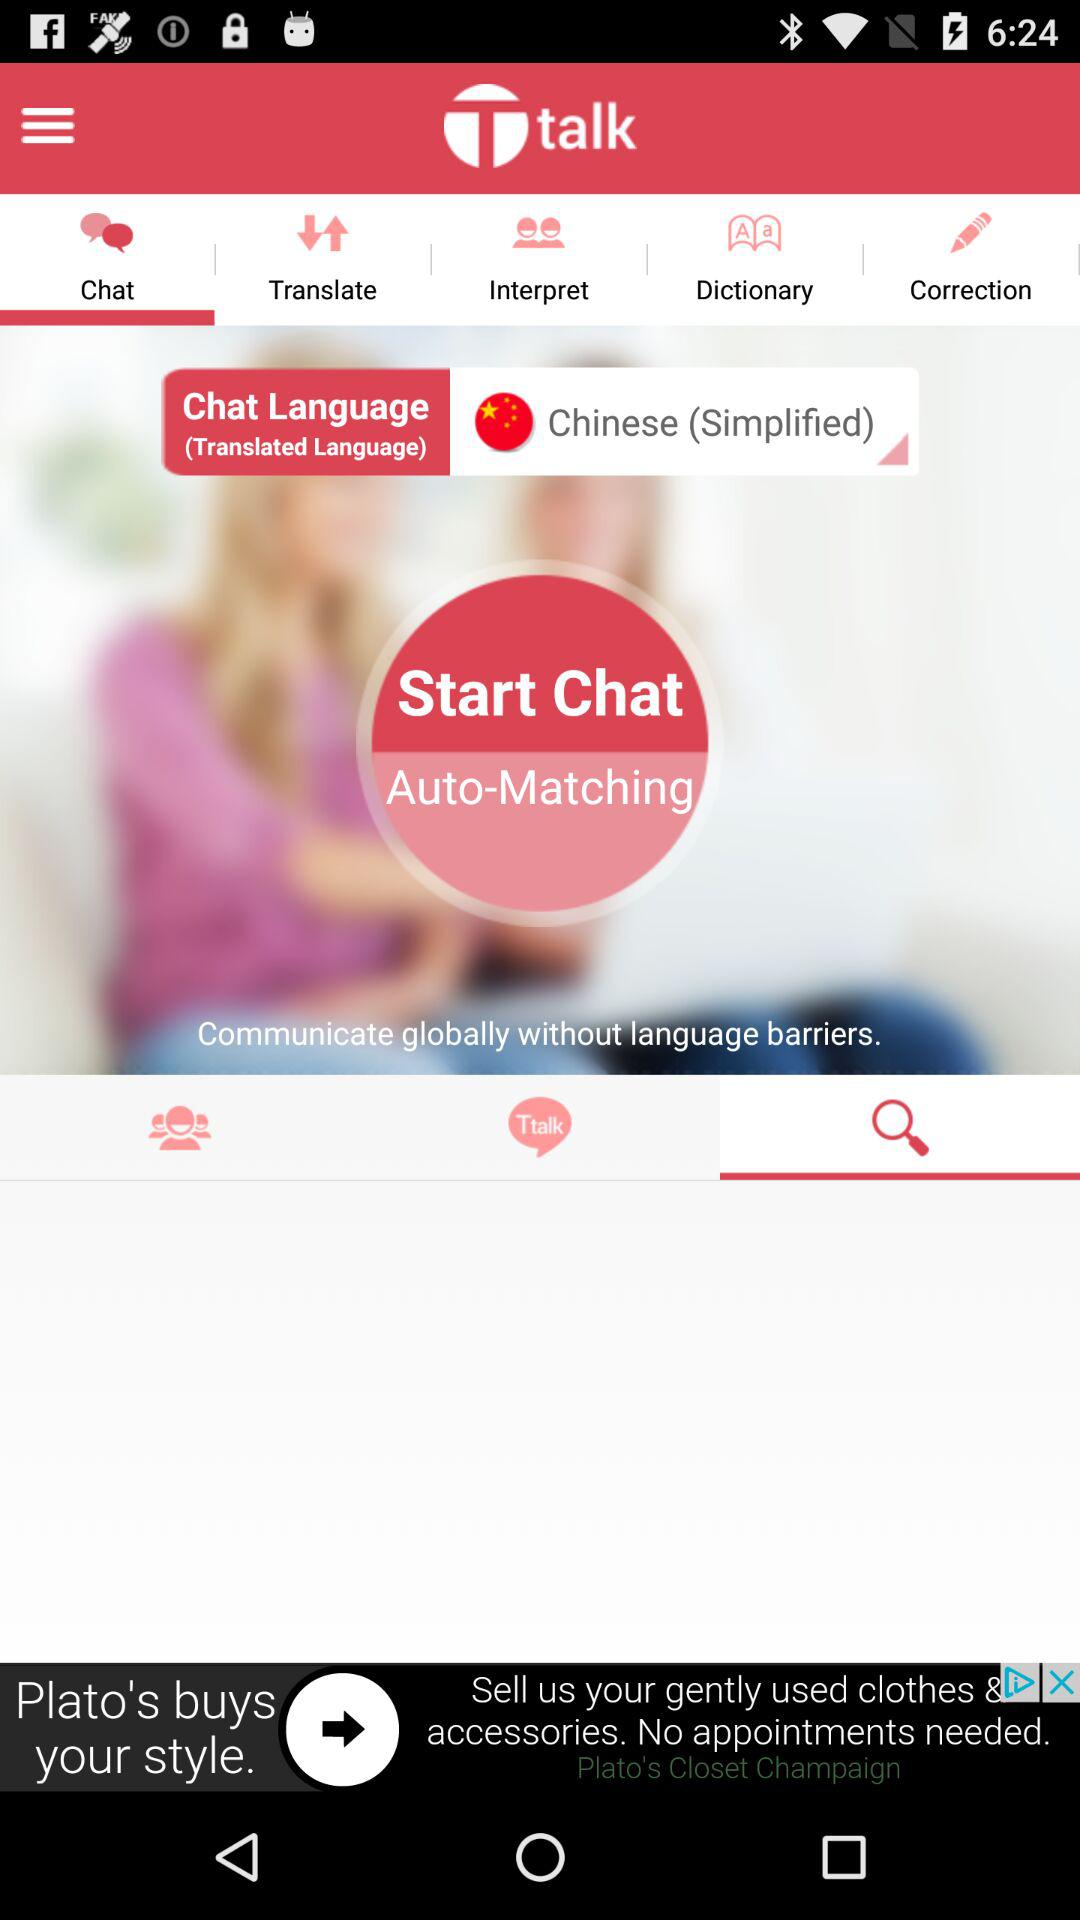How is the match paired up?
When the provided information is insufficient, respond with <no answer>. <no answer> 